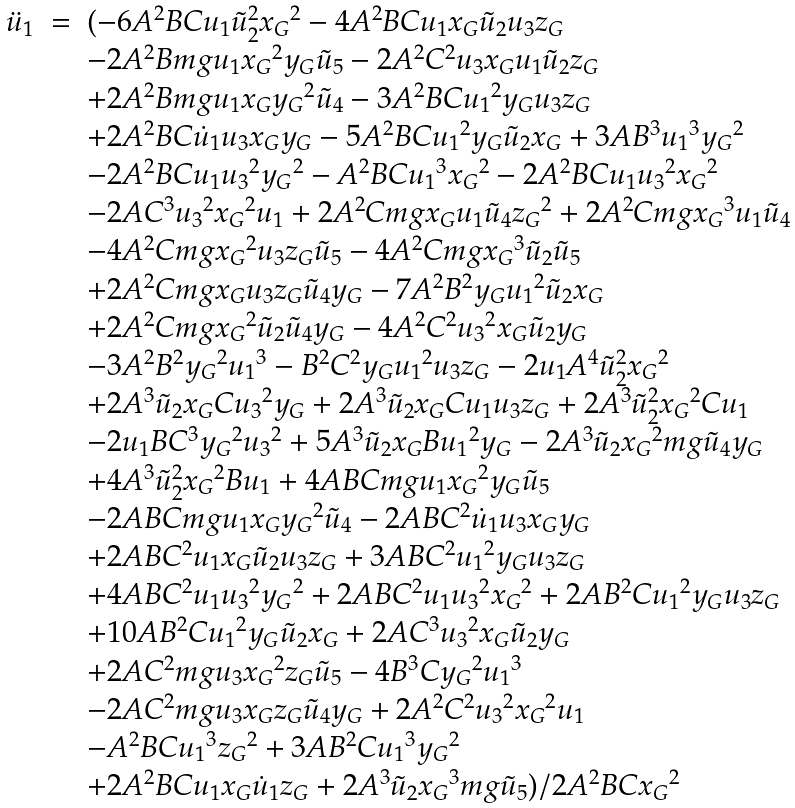Convert formula to latex. <formula><loc_0><loc_0><loc_500><loc_500>\begin{array} { r c l } \ddot { u } _ { 1 } & = & ( - 6 A ^ { 2 } B C { u _ { 1 } } { \tilde { u } _ { 2 } } ^ { 2 } { x _ { G } } ^ { 2 } - 4 A ^ { 2 } B C { u _ { 1 } } { x _ { G } } { \tilde { u } _ { 2 } } { u _ { 3 } } { z _ { G } } \\ & & - 2 A ^ { 2 } B { m g } { u _ { 1 } } { x _ { G } } ^ { 2 } { y _ { G } } { \tilde { u } _ { 5 } } - 2 A ^ { 2 } C ^ { 2 } { u _ { 3 } } { x _ { G } } { u _ { 1 } } { \tilde { u } _ { 2 } } { z _ { G } } \\ & & + 2 A ^ { 2 } B { m g } { u _ { 1 } } { x _ { G } } { y _ { G } } ^ { 2 } { \tilde { u } _ { 4 } } - 3 A ^ { 2 } B C { u _ { 1 } } ^ { 2 } { y _ { G } } { u _ { 3 } } { z _ { G } } \\ & & + 2 A ^ { 2 } B C { \dot { u } _ { 1 } } { u _ { 3 } } { x _ { G } } { y _ { G } } - 5 A ^ { 2 } B C { u _ { 1 } } ^ { 2 } { y _ { G } } { \tilde { u } _ { 2 } } { x _ { G } } + 3 A B ^ { 3 } { u _ { 1 } } ^ { 3 } { y _ { G } } ^ { 2 } \\ & & - 2 A ^ { 2 } B C { u _ { 1 } } { u _ { 3 } } ^ { 2 } { y _ { G } } ^ { 2 } - A ^ { 2 } B C { u _ { 1 } } ^ { 3 } { x _ { G } } ^ { 2 } - 2 A ^ { 2 } B C { u _ { 1 } } { u _ { 3 } } ^ { 2 } { x _ { G } } ^ { 2 } \\ & & - 2 A C ^ { 3 } { u _ { 3 } } ^ { 2 } { x _ { G } } ^ { 2 } { u _ { 1 } } + 2 A ^ { 2 } C { m g } { x _ { G } } { u _ { 1 } } { \tilde { u } _ { 4 } } { z _ { G } } ^ { 2 } + 2 A ^ { 2 } C { m g } { x _ { G } } ^ { 3 } { u _ { 1 } } { \tilde { u } _ { 4 } } \\ & & - 4 A ^ { 2 } C { m g } { x _ { G } } ^ { 2 } { u _ { 3 } } { z _ { G } } { \tilde { u } _ { 5 } } - 4 A ^ { 2 } C { m g } { x _ { G } } ^ { 3 } { \tilde { u } _ { 2 } } { \tilde { u } _ { 5 } } \\ & & + 2 A ^ { 2 } C { m g } { x _ { G } } { u _ { 3 } } { z _ { G } } { \tilde { u } _ { 4 } } { y _ { G } } - 7 A ^ { 2 } B ^ { 2 } { y _ { G } } { u _ { 1 } } ^ { 2 } { \tilde { u } _ { 2 } } { x _ { G } } \\ & & + 2 A ^ { 2 } C { m g } { x _ { G } } ^ { 2 } { \tilde { u } _ { 2 } } { \tilde { u } _ { 4 } } { y _ { G } } - 4 A ^ { 2 } C ^ { 2 } { u _ { 3 } } ^ { 2 } { x _ { G } } { \tilde { u } _ { 2 } } { y _ { G } } \\ & & - 3 A ^ { 2 } B ^ { 2 } { y _ { G } } ^ { 2 } { u _ { 1 } } ^ { 3 } - B ^ { 2 } C ^ { 2 } { y _ { G } } { u _ { 1 } } ^ { 2 } { u _ { 3 } } { z _ { G } } - 2 { u _ { 1 } } A ^ { 4 } { \tilde { u } _ { 2 } } ^ { 2 } { x _ { G } } ^ { 2 } \\ & & + 2 A ^ { 3 } { \tilde { u } _ { 2 } } { x _ { G } } C { u _ { 3 } } ^ { 2 } { y _ { G } } + 2 A ^ { 3 } { \tilde { u } _ { 2 } } { x _ { G } } C { u _ { 1 } } { u _ { 3 } } { z _ { G } } + 2 A ^ { 3 } { \tilde { u } _ { 2 } } ^ { 2 } { x _ { G } } ^ { 2 } C { u _ { 1 } } \\ & & - 2 { u _ { 1 } } B C ^ { 3 } { y _ { G } } ^ { 2 } { u _ { 3 } } ^ { 2 } + 5 A ^ { 3 } { \tilde { u } _ { 2 } } { x _ { G } } B { u _ { 1 } } ^ { 2 } { y _ { G } } - 2 A ^ { 3 } { \tilde { u } _ { 2 } } { x _ { G } } ^ { 2 } { m g } { \tilde { u } _ { 4 } } { y _ { G } } \\ & & + 4 A ^ { 3 } { \tilde { u } _ { 2 } } ^ { 2 } { x _ { G } } ^ { 2 } B { u _ { 1 } } + 4 A B C { m g } { u _ { 1 } } { x _ { G } } ^ { 2 } { y _ { G } } { \tilde { u } _ { 5 } } \\ & & - 2 A B C { m g } { u _ { 1 } } { x _ { G } } { y _ { G } } ^ { 2 } { \tilde { u } _ { 4 } } - 2 A B C ^ { 2 } { \dot { u } _ { 1 } } { u _ { 3 } } { x _ { G } } { y _ { G } } \\ & & + 2 A B C ^ { 2 } { u _ { 1 } } { x _ { G } } { \tilde { u } _ { 2 } } { u _ { 3 } } { z _ { G } } + 3 A B C ^ { 2 } { u _ { 1 } } ^ { 2 } { y _ { G } } { u _ { 3 } } { z _ { G } } \\ & & + 4 A B C ^ { 2 } { u _ { 1 } } { u _ { 3 } } ^ { 2 } { y _ { G } } ^ { 2 } + 2 A B C ^ { 2 } { u _ { 1 } } { u _ { 3 } } ^ { 2 } { x _ { G } } ^ { 2 } + 2 A B ^ { 2 } C { u _ { 1 } } ^ { 2 } { y _ { G } } { u _ { 3 } } { z _ { G } } \\ & & + 1 0 A B ^ { 2 } C { u _ { 1 } } ^ { 2 } { y _ { G } } { \tilde { u } _ { 2 } } { x _ { G } } + 2 A C ^ { 3 } { u _ { 3 } } ^ { 2 } { x _ { G } } { \tilde { u } _ { 2 } } { y _ { G } } \\ & & + 2 A C ^ { 2 } { m g } { u _ { 3 } } { x _ { G } } ^ { 2 } { z _ { G } } { \tilde { u } _ { 5 } } - 4 B ^ { 3 } C { y _ { G } } ^ { 2 } { u _ { 1 } } ^ { 3 } \\ & & - 2 A C ^ { 2 } { m g } { u _ { 3 } } { x _ { G } } { z _ { G } } { \tilde { u } _ { 4 } } { y _ { G } } + 2 A ^ { 2 } C ^ { 2 } { u _ { 3 } } ^ { 2 } { x _ { G } } ^ { 2 } { u _ { 1 } } \\ & & - A ^ { 2 } B C { u _ { 1 } } ^ { 3 } { z _ { G } } ^ { 2 } + 3 A B ^ { 2 } C { u _ { 1 } } ^ { 3 } { y _ { G } } ^ { 2 } \\ & & + 2 A ^ { 2 } B C { u _ { 1 } } { x _ { G } } { \dot { u } _ { 1 } } { z _ { G } } + 2 A ^ { 3 } { \tilde { u } _ { 2 } } { x _ { G } } ^ { 3 } { m g } { \tilde { u } _ { 5 } } ) / 2 A ^ { 2 } B C { x _ { G } } ^ { 2 } \end{array}</formula> 